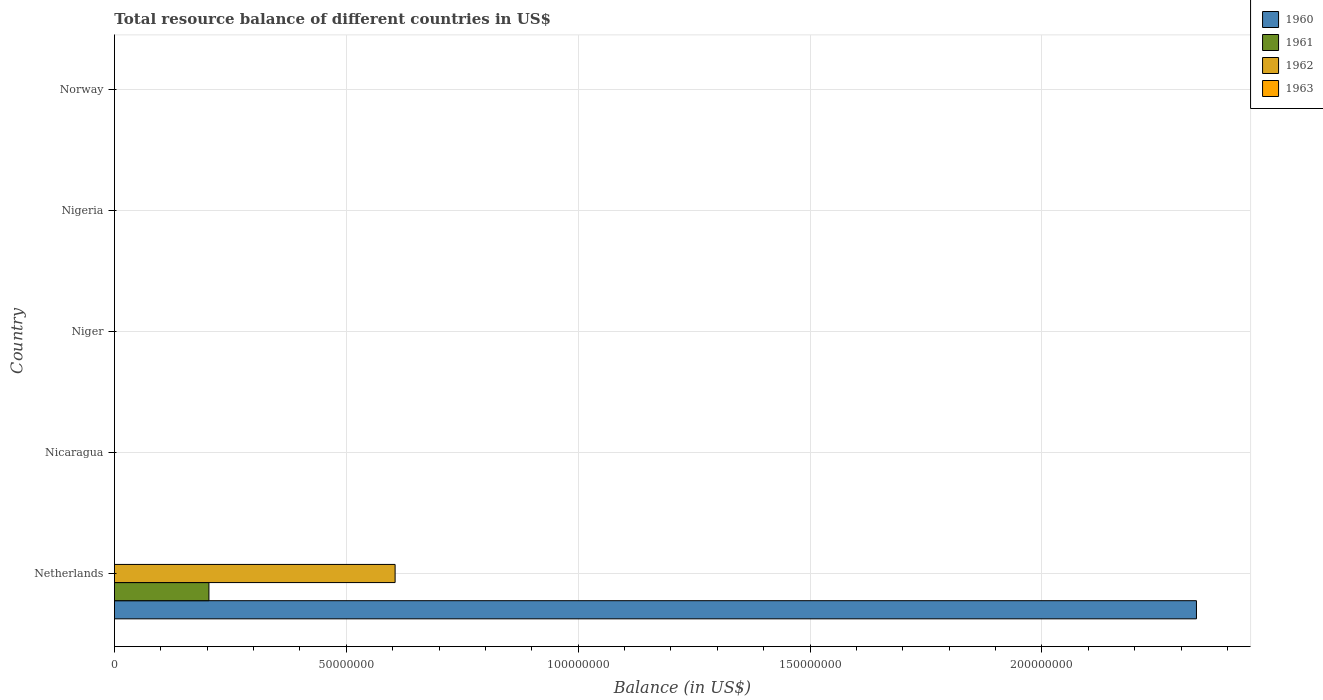Are the number of bars on each tick of the Y-axis equal?
Offer a terse response. No. How many bars are there on the 4th tick from the top?
Offer a terse response. 0. What is the label of the 4th group of bars from the top?
Your response must be concise. Nicaragua. In how many cases, is the number of bars for a given country not equal to the number of legend labels?
Offer a very short reply. 5. What is the total resource balance in 1960 in Norway?
Your answer should be compact. 0. Across all countries, what is the maximum total resource balance in 1961?
Provide a short and direct response. 2.04e+07. Across all countries, what is the minimum total resource balance in 1961?
Offer a very short reply. 0. In which country was the total resource balance in 1961 maximum?
Your response must be concise. Netherlands. What is the total total resource balance in 1962 in the graph?
Offer a terse response. 6.05e+07. What is the difference between the total resource balance in 1962 and total resource balance in 1960 in Netherlands?
Provide a succinct answer. -1.73e+08. In how many countries, is the total resource balance in 1961 greater than 50000000 US$?
Ensure brevity in your answer.  0. What is the difference between the highest and the lowest total resource balance in 1961?
Make the answer very short. 2.04e+07. Is it the case that in every country, the sum of the total resource balance in 1963 and total resource balance in 1960 is greater than the total resource balance in 1962?
Provide a short and direct response. No. Are the values on the major ticks of X-axis written in scientific E-notation?
Make the answer very short. No. How many legend labels are there?
Give a very brief answer. 4. What is the title of the graph?
Your answer should be very brief. Total resource balance of different countries in US$. Does "1966" appear as one of the legend labels in the graph?
Make the answer very short. No. What is the label or title of the X-axis?
Offer a very short reply. Balance (in US$). What is the label or title of the Y-axis?
Your answer should be very brief. Country. What is the Balance (in US$) of 1960 in Netherlands?
Give a very brief answer. 2.33e+08. What is the Balance (in US$) of 1961 in Netherlands?
Your response must be concise. 2.04e+07. What is the Balance (in US$) in 1962 in Netherlands?
Your answer should be compact. 6.05e+07. What is the Balance (in US$) in 1961 in Nicaragua?
Your answer should be very brief. 0. What is the Balance (in US$) in 1962 in Nicaragua?
Provide a short and direct response. 0. What is the Balance (in US$) in 1963 in Niger?
Your answer should be very brief. 0. What is the Balance (in US$) of 1960 in Nigeria?
Keep it short and to the point. 0. What is the Balance (in US$) of 1963 in Nigeria?
Your answer should be very brief. 0. What is the Balance (in US$) of 1960 in Norway?
Offer a terse response. 0. What is the Balance (in US$) of 1963 in Norway?
Your response must be concise. 0. Across all countries, what is the maximum Balance (in US$) in 1960?
Your answer should be compact. 2.33e+08. Across all countries, what is the maximum Balance (in US$) in 1961?
Provide a short and direct response. 2.04e+07. Across all countries, what is the maximum Balance (in US$) of 1962?
Offer a very short reply. 6.05e+07. Across all countries, what is the minimum Balance (in US$) in 1960?
Provide a short and direct response. 0. Across all countries, what is the minimum Balance (in US$) in 1962?
Ensure brevity in your answer.  0. What is the total Balance (in US$) in 1960 in the graph?
Provide a succinct answer. 2.33e+08. What is the total Balance (in US$) in 1961 in the graph?
Your answer should be very brief. 2.04e+07. What is the total Balance (in US$) of 1962 in the graph?
Provide a short and direct response. 6.05e+07. What is the total Balance (in US$) in 1963 in the graph?
Provide a short and direct response. 0. What is the average Balance (in US$) in 1960 per country?
Provide a succinct answer. 4.67e+07. What is the average Balance (in US$) in 1961 per country?
Offer a terse response. 4.07e+06. What is the average Balance (in US$) of 1962 per country?
Your answer should be compact. 1.21e+07. What is the difference between the Balance (in US$) of 1960 and Balance (in US$) of 1961 in Netherlands?
Your answer should be very brief. 2.13e+08. What is the difference between the Balance (in US$) of 1960 and Balance (in US$) of 1962 in Netherlands?
Keep it short and to the point. 1.73e+08. What is the difference between the Balance (in US$) in 1961 and Balance (in US$) in 1962 in Netherlands?
Provide a short and direct response. -4.01e+07. What is the difference between the highest and the lowest Balance (in US$) of 1960?
Give a very brief answer. 2.33e+08. What is the difference between the highest and the lowest Balance (in US$) of 1961?
Ensure brevity in your answer.  2.04e+07. What is the difference between the highest and the lowest Balance (in US$) in 1962?
Your answer should be compact. 6.05e+07. 